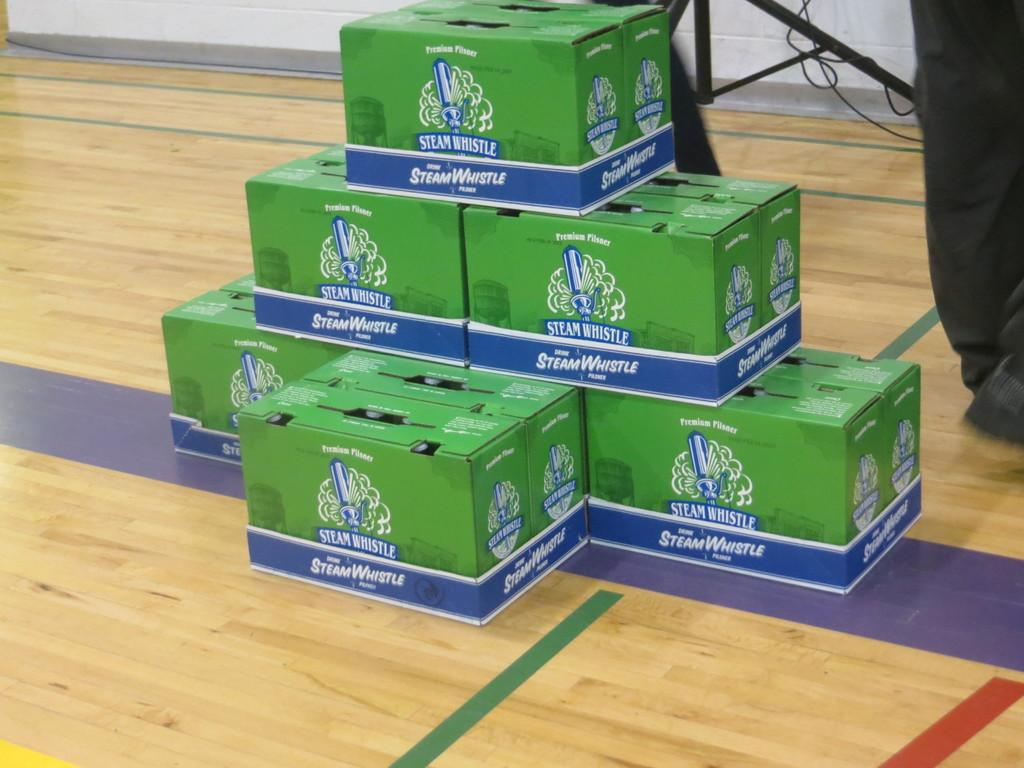<image>
Render a clear and concise summary of the photo. Boxes with bottles in them saying Steam Whistle. 